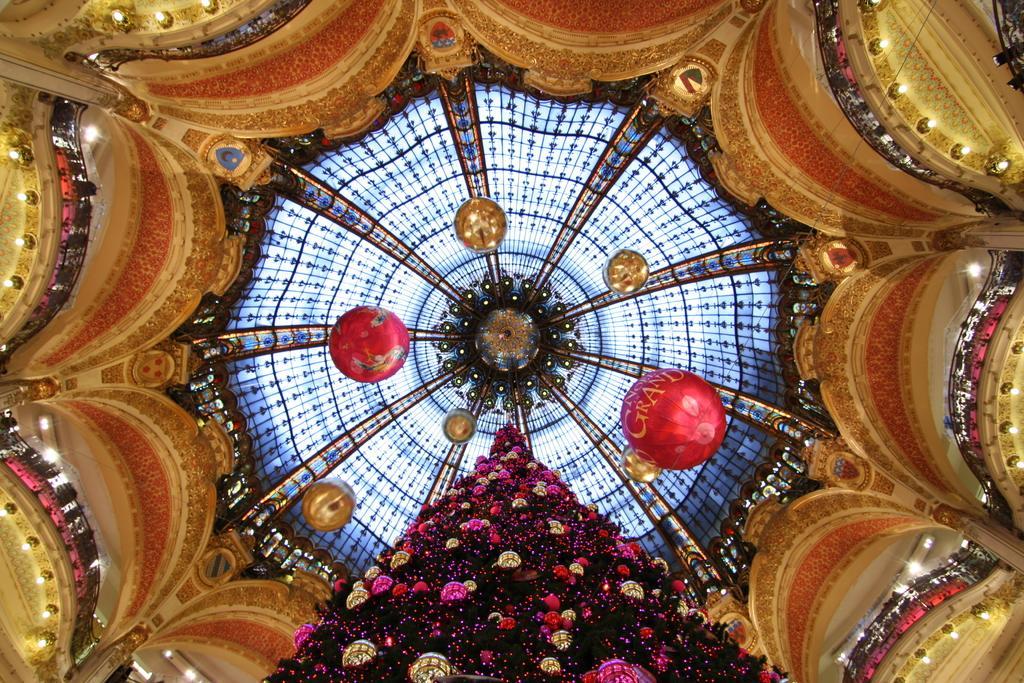How would you summarize this image in a sentence or two? In this image I can see a Christmas tree which is black, pink and gold in color and I can see few decorations on it which are pink in color. In the background I can see the rooftop of the building which is gold, red, black and blue in color and I can see few lights around the roof. 